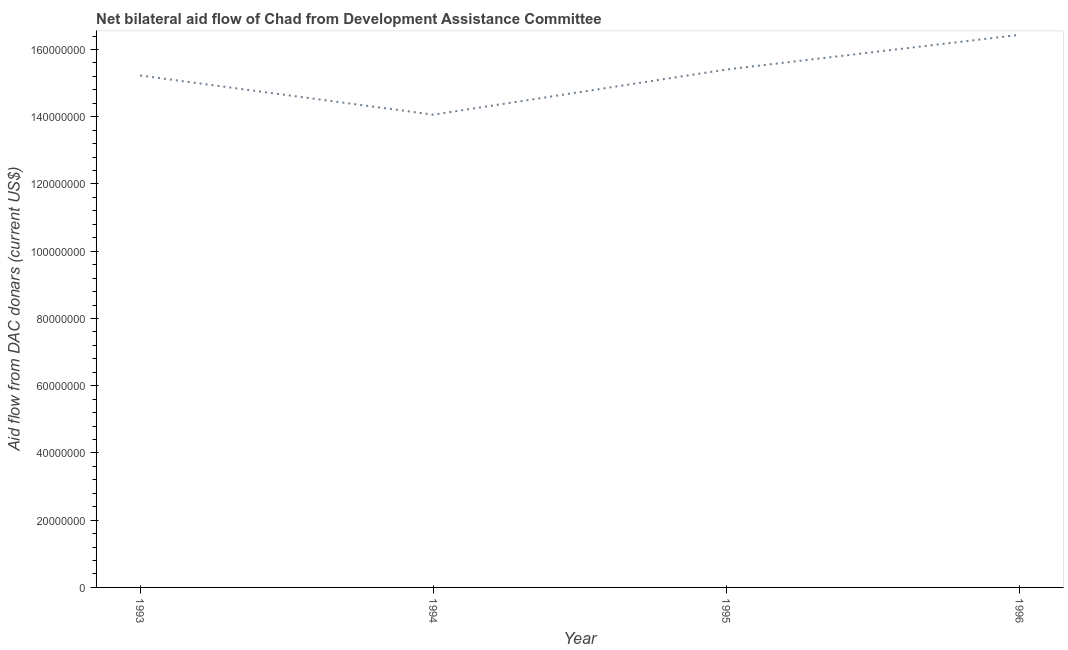What is the net bilateral aid flows from dac donors in 1993?
Provide a succinct answer. 1.52e+08. Across all years, what is the maximum net bilateral aid flows from dac donors?
Provide a short and direct response. 1.64e+08. Across all years, what is the minimum net bilateral aid flows from dac donors?
Keep it short and to the point. 1.41e+08. In which year was the net bilateral aid flows from dac donors maximum?
Your response must be concise. 1996. In which year was the net bilateral aid flows from dac donors minimum?
Provide a short and direct response. 1994. What is the sum of the net bilateral aid flows from dac donors?
Keep it short and to the point. 6.11e+08. What is the difference between the net bilateral aid flows from dac donors in 1993 and 1994?
Give a very brief answer. 1.16e+07. What is the average net bilateral aid flows from dac donors per year?
Your answer should be compact. 1.53e+08. What is the median net bilateral aid flows from dac donors?
Offer a very short reply. 1.53e+08. In how many years, is the net bilateral aid flows from dac donors greater than 112000000 US$?
Make the answer very short. 4. Do a majority of the years between 1996 and 1993 (inclusive) have net bilateral aid flows from dac donors greater than 148000000 US$?
Ensure brevity in your answer.  Yes. What is the ratio of the net bilateral aid flows from dac donors in 1994 to that in 1996?
Offer a terse response. 0.86. What is the difference between the highest and the second highest net bilateral aid flows from dac donors?
Your response must be concise. 1.03e+07. Is the sum of the net bilateral aid flows from dac donors in 1993 and 1994 greater than the maximum net bilateral aid flows from dac donors across all years?
Your response must be concise. Yes. What is the difference between the highest and the lowest net bilateral aid flows from dac donors?
Your answer should be compact. 2.38e+07. In how many years, is the net bilateral aid flows from dac donors greater than the average net bilateral aid flows from dac donors taken over all years?
Your response must be concise. 2. What is the difference between two consecutive major ticks on the Y-axis?
Provide a succinct answer. 2.00e+07. Are the values on the major ticks of Y-axis written in scientific E-notation?
Your response must be concise. No. Does the graph contain grids?
Your response must be concise. No. What is the title of the graph?
Keep it short and to the point. Net bilateral aid flow of Chad from Development Assistance Committee. What is the label or title of the X-axis?
Provide a short and direct response. Year. What is the label or title of the Y-axis?
Your response must be concise. Aid flow from DAC donars (current US$). What is the Aid flow from DAC donars (current US$) of 1993?
Keep it short and to the point. 1.52e+08. What is the Aid flow from DAC donars (current US$) of 1994?
Offer a terse response. 1.41e+08. What is the Aid flow from DAC donars (current US$) in 1995?
Keep it short and to the point. 1.54e+08. What is the Aid flow from DAC donars (current US$) in 1996?
Give a very brief answer. 1.64e+08. What is the difference between the Aid flow from DAC donars (current US$) in 1993 and 1994?
Make the answer very short. 1.16e+07. What is the difference between the Aid flow from DAC donars (current US$) in 1993 and 1995?
Your answer should be compact. -1.78e+06. What is the difference between the Aid flow from DAC donars (current US$) in 1993 and 1996?
Keep it short and to the point. -1.21e+07. What is the difference between the Aid flow from DAC donars (current US$) in 1994 and 1995?
Keep it short and to the point. -1.34e+07. What is the difference between the Aid flow from DAC donars (current US$) in 1994 and 1996?
Your answer should be compact. -2.38e+07. What is the difference between the Aid flow from DAC donars (current US$) in 1995 and 1996?
Provide a short and direct response. -1.03e+07. What is the ratio of the Aid flow from DAC donars (current US$) in 1993 to that in 1994?
Keep it short and to the point. 1.08. What is the ratio of the Aid flow from DAC donars (current US$) in 1993 to that in 1995?
Provide a short and direct response. 0.99. What is the ratio of the Aid flow from DAC donars (current US$) in 1993 to that in 1996?
Offer a very short reply. 0.93. What is the ratio of the Aid flow from DAC donars (current US$) in 1994 to that in 1995?
Provide a succinct answer. 0.91. What is the ratio of the Aid flow from DAC donars (current US$) in 1994 to that in 1996?
Offer a terse response. 0.86. What is the ratio of the Aid flow from DAC donars (current US$) in 1995 to that in 1996?
Your response must be concise. 0.94. 